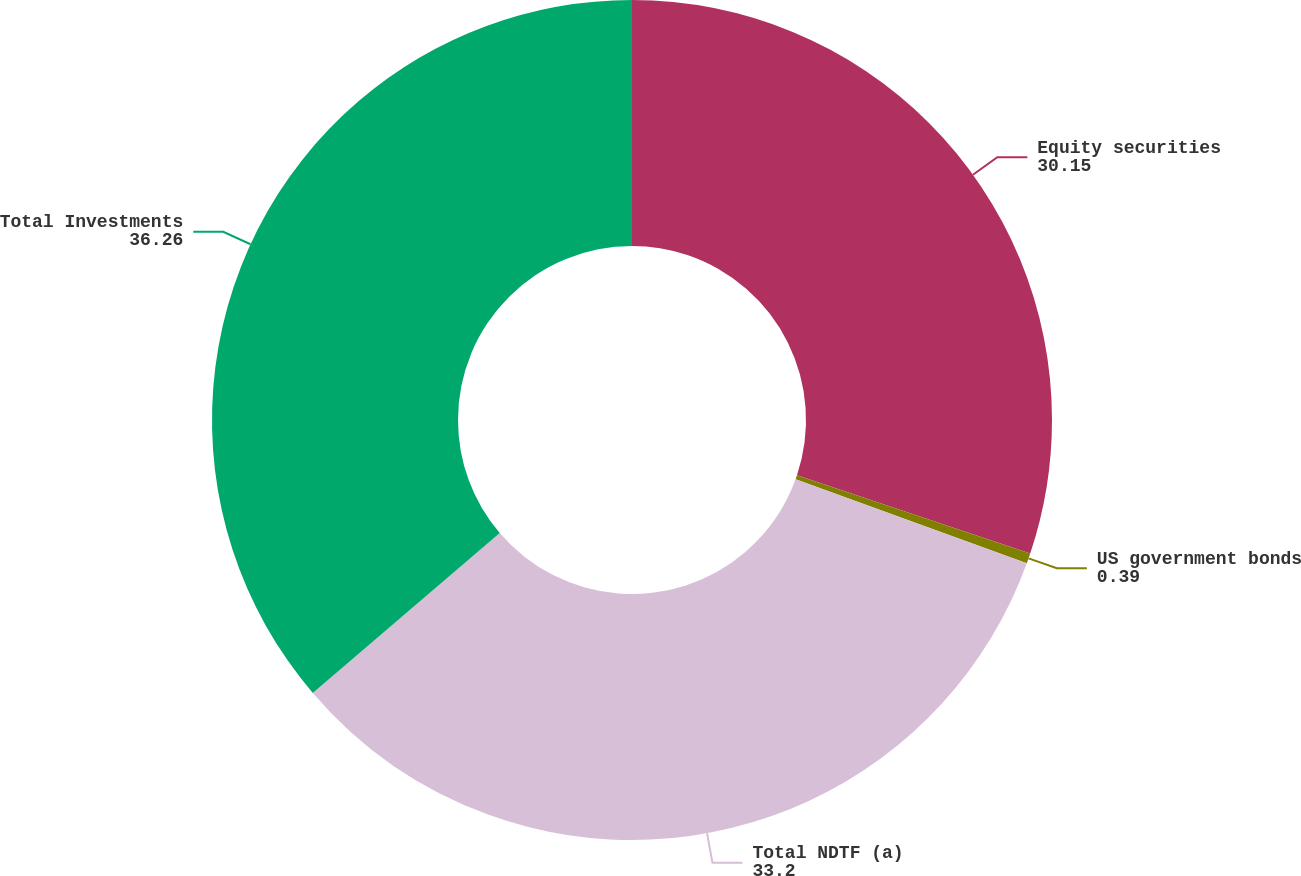Convert chart to OTSL. <chart><loc_0><loc_0><loc_500><loc_500><pie_chart><fcel>Equity securities<fcel>US government bonds<fcel>Total NDTF (a)<fcel>Total Investments<nl><fcel>30.15%<fcel>0.39%<fcel>33.2%<fcel>36.26%<nl></chart> 